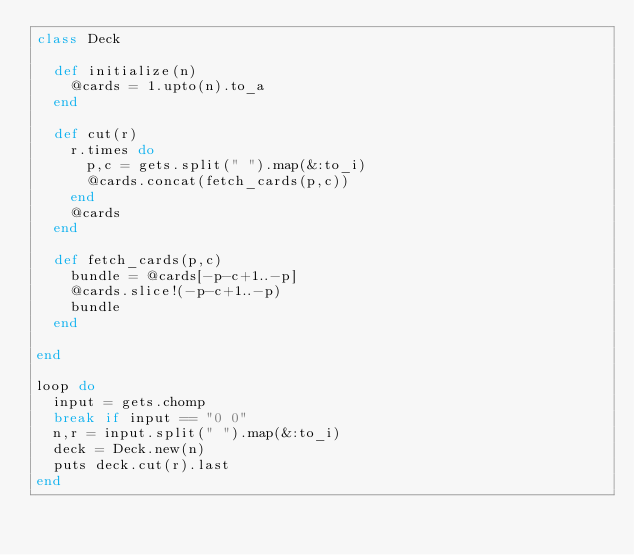<code> <loc_0><loc_0><loc_500><loc_500><_Ruby_>class Deck

  def initialize(n)
    @cards = 1.upto(n).to_a
  end 

  def cut(r)
    r.times do
      p,c = gets.split(" ").map(&:to_i)
      @cards.concat(fetch_cards(p,c))
    end 
    @cards
  end 

  def fetch_cards(p,c)
    bundle = @cards[-p-c+1..-p]
    @cards.slice!(-p-c+1..-p)
    bundle
  end 

end

loop do
  input = gets.chomp
  break if input == "0 0"
  n,r = input.split(" ").map(&:to_i)
  deck = Deck.new(n)
  puts deck.cut(r).last
end</code> 